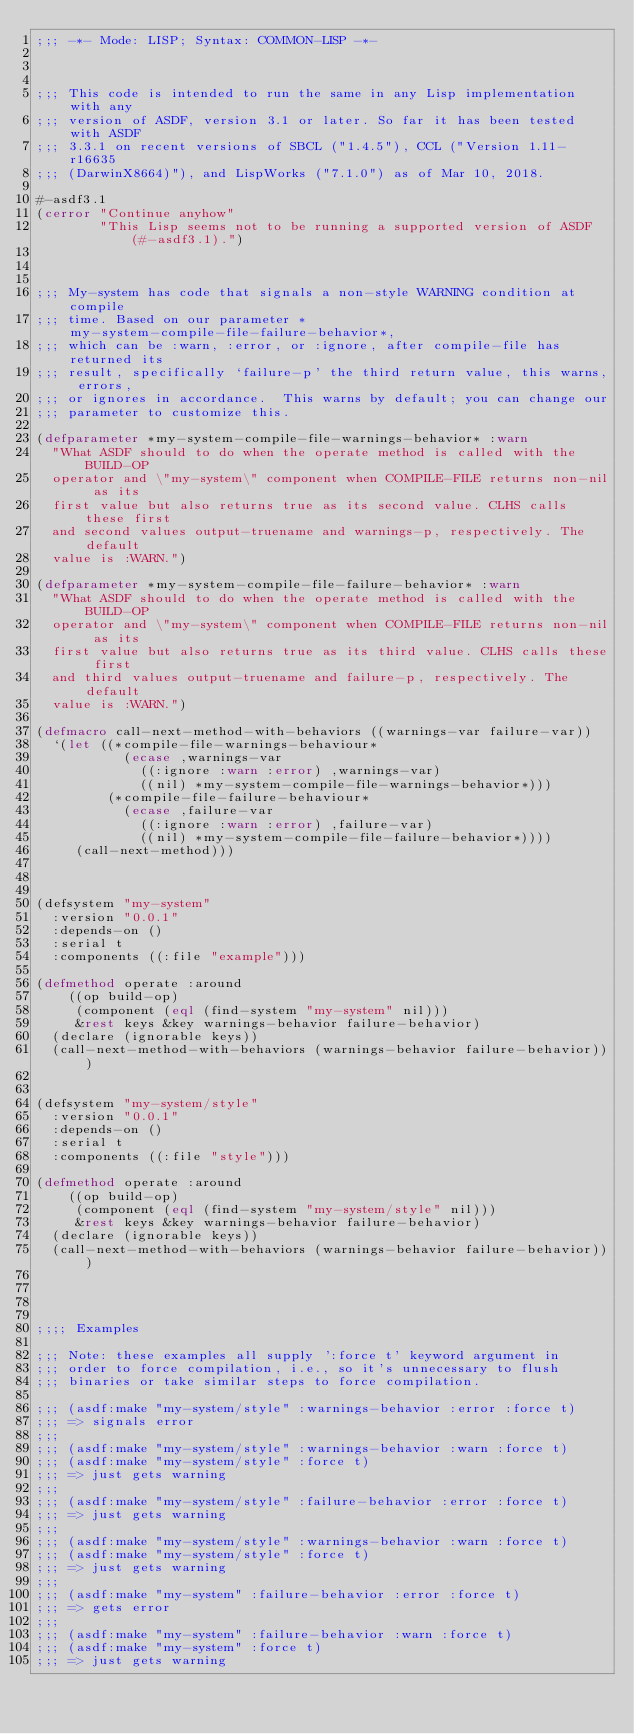Convert code to text. <code><loc_0><loc_0><loc_500><loc_500><_Lisp_>;;; -*- Mode: LISP; Syntax: COMMON-LISP -*-



;;; This code is intended to run the same in any Lisp implementation with any
;;; version of ASDF, version 3.1 or later. So far it has been tested with ASDF
;;; 3.3.1 on recent versions of SBCL ("1.4.5"), CCL ("Version 1.11-r16635
;;; (DarwinX8664)"), and LispWorks ("7.1.0") as of Mar 10, 2018.

#-asdf3.1 
(cerror "Continue anyhow" 
        "This Lisp seems not to be running a supported version of ASDF (#-asdf3.1).")



;;; My-system has code that signals a non-style WARNING condition at compile
;;; time. Based on our parameter *my-system-compile-file-failure-behavior*,
;;; which can be :warn, :error, or :ignore, after compile-file has returned its
;;; result, specifically `failure-p' the third return value, this warns, errors,
;;; or ignores in accordance.  This warns by default; you can change our
;;; parameter to customize this.

(defparameter *my-system-compile-file-warnings-behavior* :warn
  "What ASDF should to do when the operate method is called with the BUILD-OP
  operator and \"my-system\" component when COMPILE-FILE returns non-nil as its
  first value but also returns true as its second value. CLHS calls these first
  and second values output-truename and warnings-p, respectively. The default
  value is :WARN.")

(defparameter *my-system-compile-file-failure-behavior* :warn
  "What ASDF should to do when the operate method is called with the BUILD-OP
  operator and \"my-system\" component when COMPILE-FILE returns non-nil as its
  first value but also returns true as its third value. CLHS calls these first
  and third values output-truename and failure-p, respectively. The default
  value is :WARN.")

(defmacro call-next-method-with-behaviors ((warnings-var failure-var))
  `(let ((*compile-file-warnings-behaviour*
           (ecase ,warnings-var
             ((:ignore :warn :error) ,warnings-var)
             ((nil) *my-system-compile-file-warnings-behavior*)))
         (*compile-file-failure-behaviour*
           (ecase ,failure-var
             ((:ignore :warn :error) ,failure-var)
             ((nil) *my-system-compile-file-failure-behavior*))))
     (call-next-method)))



(defsystem "my-system"
  :version "0.0.1"
  :depends-on ()
  :serial t
  :components ((:file "example")))

(defmethod operate :around 
    ((op build-op) 
     (component (eql (find-system "my-system" nil)))
     &rest keys &key warnings-behavior failure-behavior)
  (declare (ignorable keys))  
  (call-next-method-with-behaviors (warnings-behavior failure-behavior)))


(defsystem "my-system/style"
  :version "0.0.1"
  :depends-on ()
  :serial t
  :components ((:file "style")))

(defmethod operate :around 
    ((op build-op) 
     (component (eql (find-system "my-system/style" nil)))
     &rest keys &key warnings-behavior failure-behavior)
  (declare (ignorable keys))  
  (call-next-method-with-behaviors (warnings-behavior failure-behavior)))




;;;; Examples

;;; Note: these examples all supply ':force t' keyword argument in
;;; order to force compilation, i.e., so it's unnecessary to flush
;;; binaries or take similar steps to force compilation.

;;; (asdf:make "my-system/style" :warnings-behavior :error :force t)
;;; => signals error
;;;
;;; (asdf:make "my-system/style" :warnings-behavior :warn :force t)
;;; (asdf:make "my-system/style" :force t)
;;; => just gets warning
;;;
;;; (asdf:make "my-system/style" :failure-behavior :error :force t)
;;; => just gets warning
;;;
;;; (asdf:make "my-system/style" :warnings-behavior :warn :force t)
;;; (asdf:make "my-system/style" :force t)
;;; => just gets warning
;;;
;;; (asdf:make "my-system" :failure-behavior :error :force t)
;;; => gets error
;;;
;;; (asdf:make "my-system" :failure-behavior :warn :force t)
;;; (asdf:make "my-system" :force t)
;;; => just gets warning
</code> 